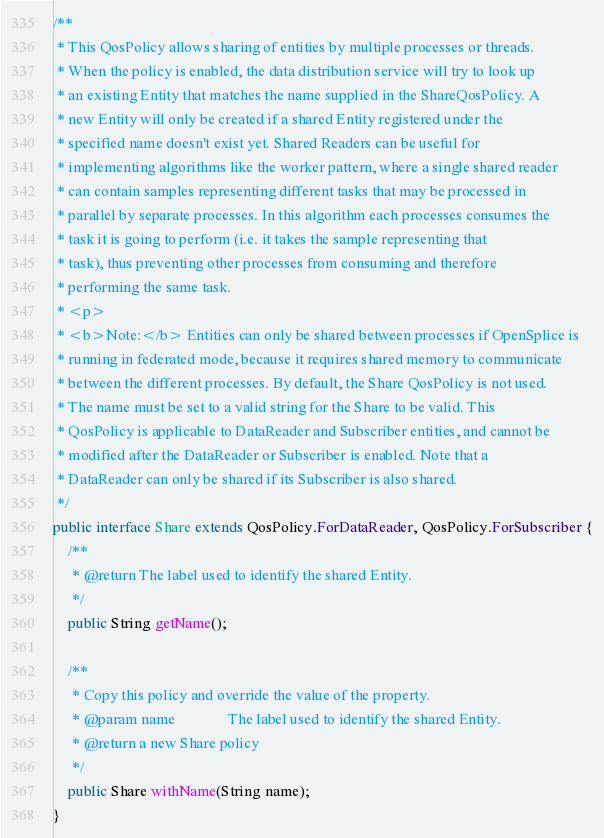Convert code to text. <code><loc_0><loc_0><loc_500><loc_500><_Java_>
/**
 * This QosPolicy allows sharing of entities by multiple processes or threads.
 * When the policy is enabled, the data distribution service will try to look up
 * an existing Entity that matches the name supplied in the ShareQosPolicy. A
 * new Entity will only be created if a shared Entity registered under the
 * specified name doesn't exist yet. Shared Readers can be useful for
 * implementing algorithms like the worker pattern, where a single shared reader
 * can contain samples representing different tasks that may be processed in
 * parallel by separate processes. In this algorithm each processes consumes the
 * task it is going to perform (i.e. it takes the sample representing that
 * task), thus preventing other processes from consuming and therefore
 * performing the same task.
 * <p>
 * <b>Note:</b> Entities can only be shared between processes if OpenSplice is
 * running in federated mode, because it requires shared memory to communicate
 * between the different processes. By default, the Share QosPolicy is not used.
 * The name must be set to a valid string for the Share to be valid. This
 * QosPolicy is applicable to DataReader and Subscriber entities, and cannot be
 * modified after the DataReader or Subscriber is enabled. Note that a
 * DataReader can only be shared if its Subscriber is also shared.
 */
public interface Share extends QosPolicy.ForDataReader, QosPolicy.ForSubscriber {
    /**
     * @return The label used to identify the shared Entity.
     */
    public String getName();

    /**
     * Copy this policy and override the value of the property.
     * @param name              The label used to identify the shared Entity.
     * @return a new Share policy
     */
    public Share withName(String name);
}
</code> 